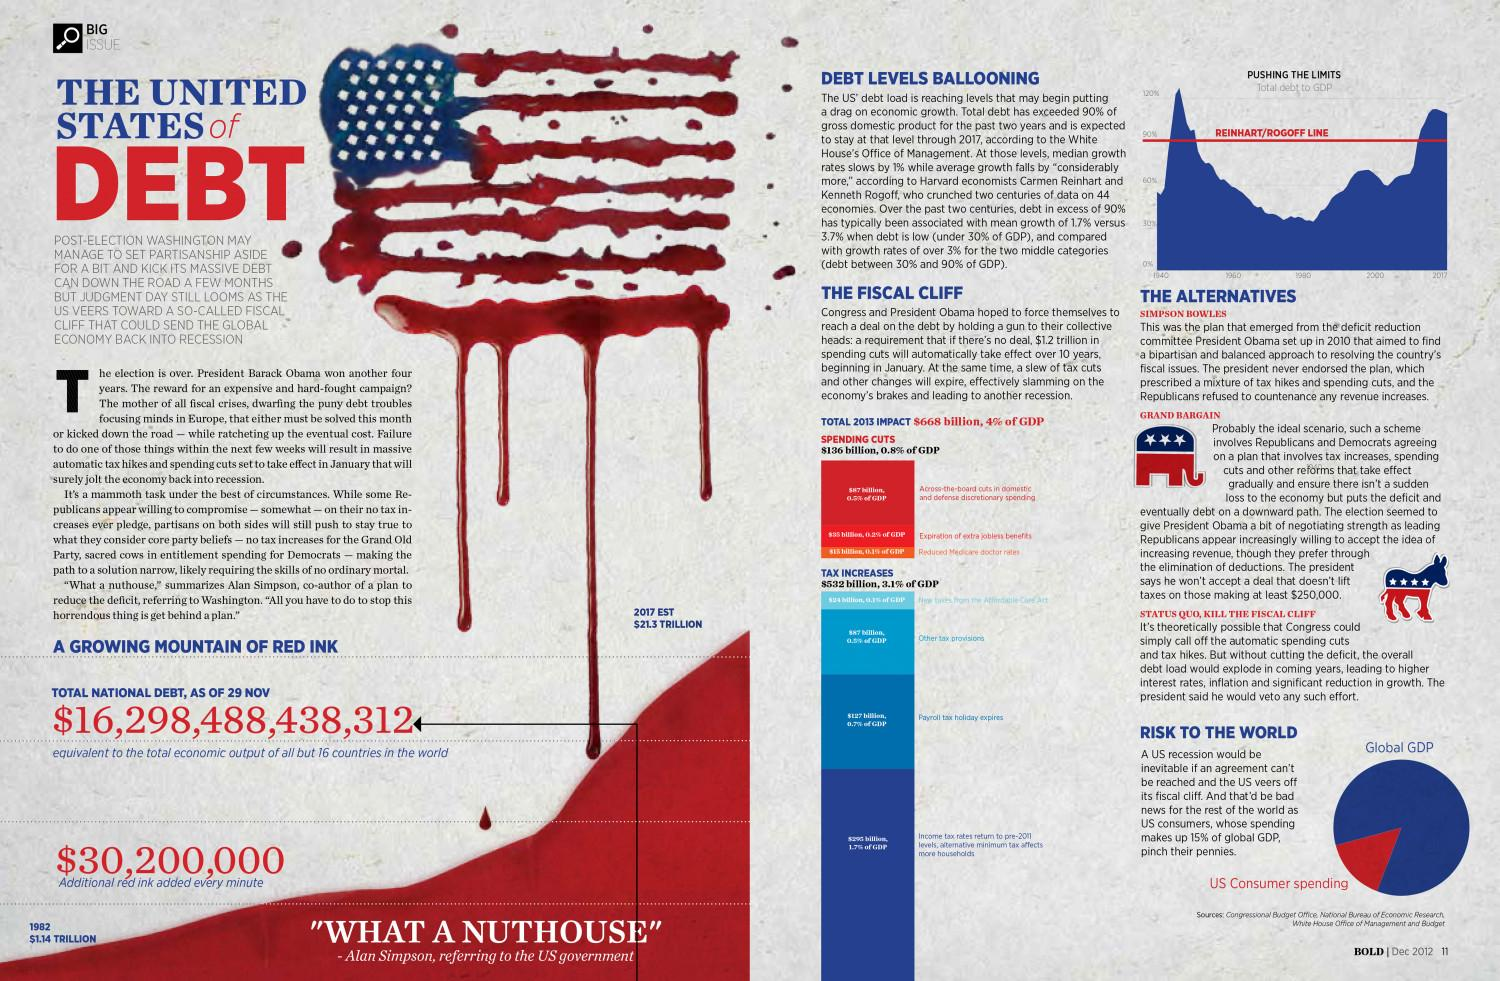List a handful of essential elements in this visual. If no agreement is reached, $1.2 trillion in spending cuts will automatically take effect over the next 10 years. 